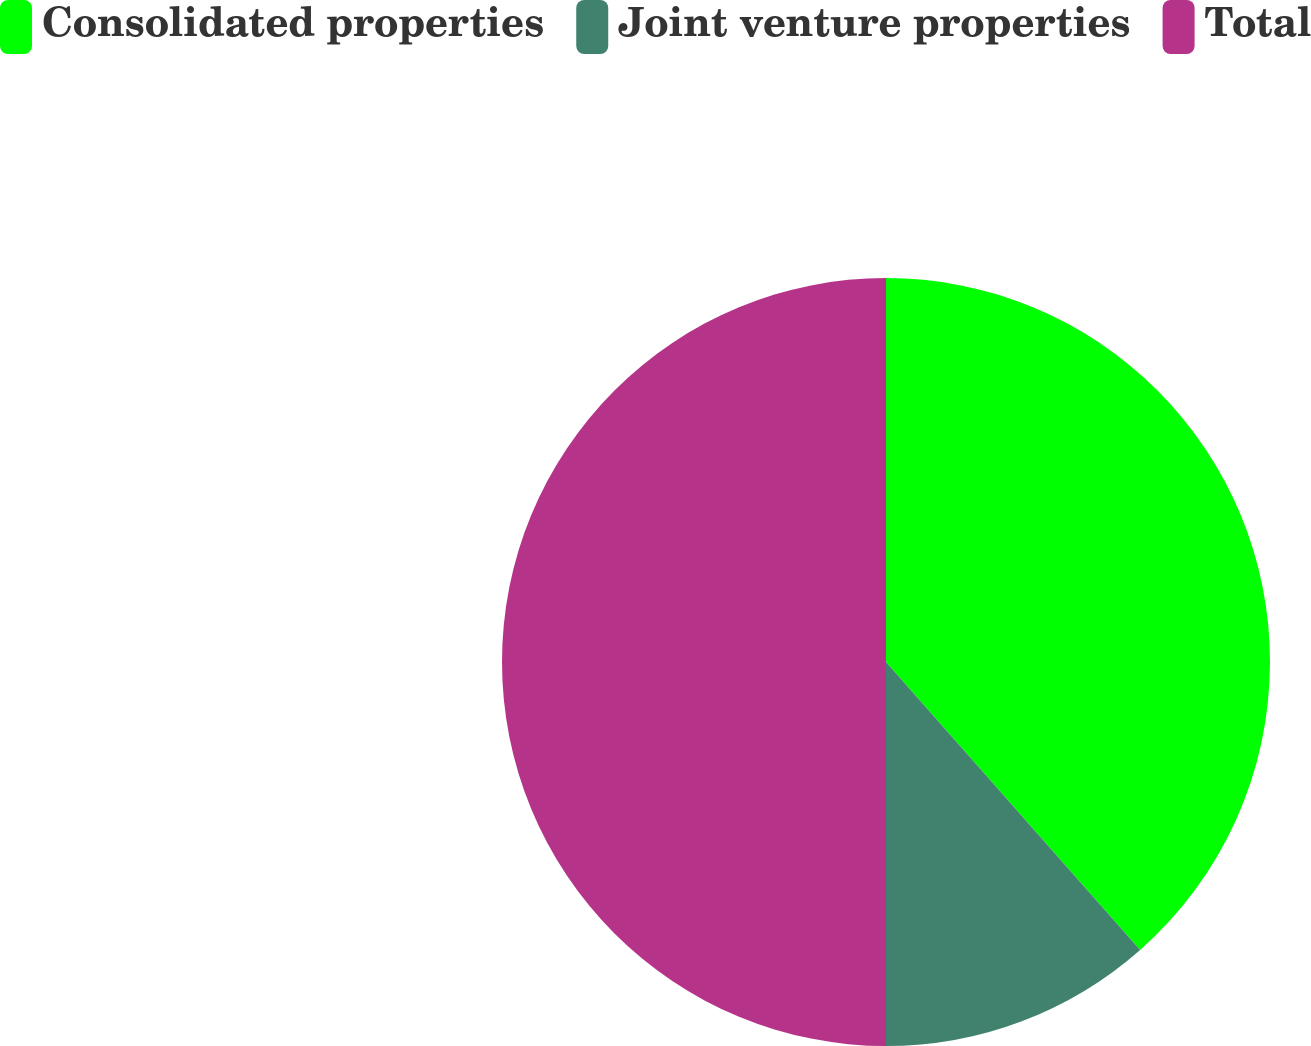Convert chart. <chart><loc_0><loc_0><loc_500><loc_500><pie_chart><fcel>Consolidated properties<fcel>Joint venture properties<fcel>Total<nl><fcel>38.49%<fcel>11.51%<fcel>50.0%<nl></chart> 